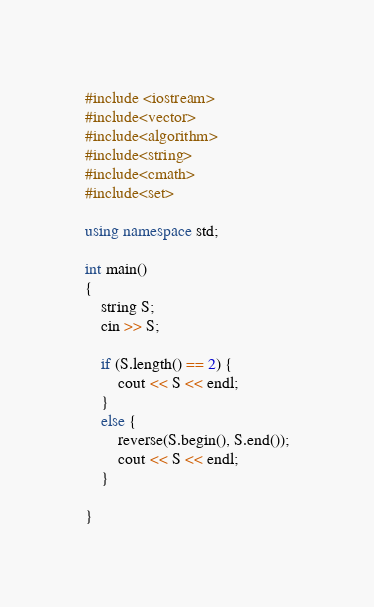Convert code to text. <code><loc_0><loc_0><loc_500><loc_500><_C++_>#include <iostream>
#include<vector>
#include<algorithm>
#include<string>
#include<cmath>
#include<set>

using namespace std;

int main()
{
	string S;
	cin >> S;

	if (S.length() == 2) {
		cout << S << endl;
	}
	else {
		reverse(S.begin(), S.end());
		cout << S << endl;
	}

}




</code> 